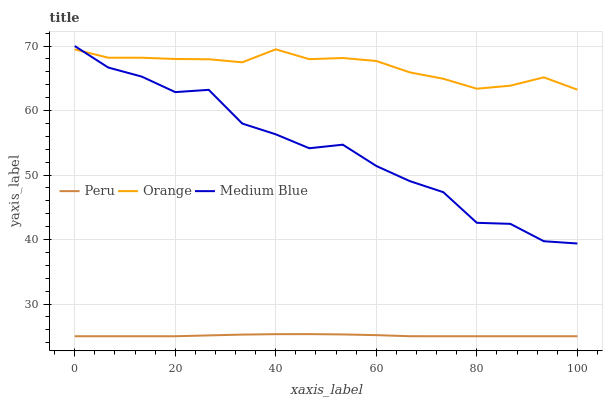Does Peru have the minimum area under the curve?
Answer yes or no. Yes. Does Orange have the maximum area under the curve?
Answer yes or no. Yes. Does Medium Blue have the minimum area under the curve?
Answer yes or no. No. Does Medium Blue have the maximum area under the curve?
Answer yes or no. No. Is Peru the smoothest?
Answer yes or no. Yes. Is Medium Blue the roughest?
Answer yes or no. Yes. Is Medium Blue the smoothest?
Answer yes or no. No. Is Peru the roughest?
Answer yes or no. No. Does Peru have the lowest value?
Answer yes or no. Yes. Does Medium Blue have the lowest value?
Answer yes or no. No. Does Medium Blue have the highest value?
Answer yes or no. Yes. Does Peru have the highest value?
Answer yes or no. No. Is Peru less than Medium Blue?
Answer yes or no. Yes. Is Orange greater than Peru?
Answer yes or no. Yes. Does Orange intersect Medium Blue?
Answer yes or no. Yes. Is Orange less than Medium Blue?
Answer yes or no. No. Is Orange greater than Medium Blue?
Answer yes or no. No. Does Peru intersect Medium Blue?
Answer yes or no. No. 